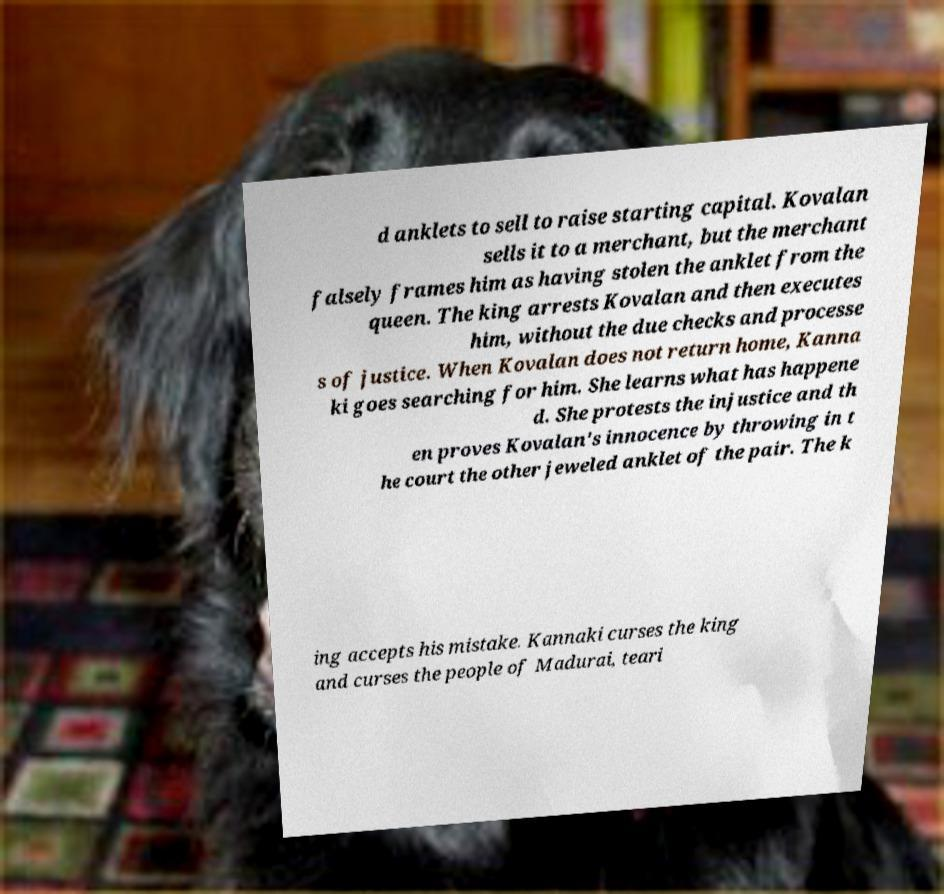Can you accurately transcribe the text from the provided image for me? d anklets to sell to raise starting capital. Kovalan sells it to a merchant, but the merchant falsely frames him as having stolen the anklet from the queen. The king arrests Kovalan and then executes him, without the due checks and processe s of justice. When Kovalan does not return home, Kanna ki goes searching for him. She learns what has happene d. She protests the injustice and th en proves Kovalan's innocence by throwing in t he court the other jeweled anklet of the pair. The k ing accepts his mistake. Kannaki curses the king and curses the people of Madurai, teari 